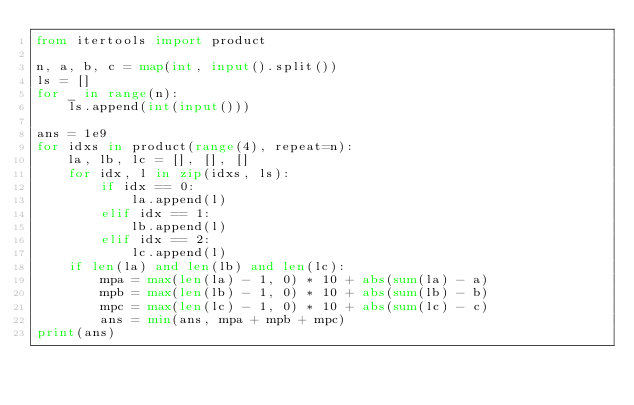<code> <loc_0><loc_0><loc_500><loc_500><_Python_>from itertools import product

n, a, b, c = map(int, input().split())
ls = []
for _ in range(n):
    ls.append(int(input()))

ans = 1e9
for idxs in product(range(4), repeat=n):
    la, lb, lc = [], [], []
    for idx, l in zip(idxs, ls):
        if idx == 0:
            la.append(l)
        elif idx == 1:
            lb.append(l)
        elif idx == 2:
            lc.append(l)
    if len(la) and len(lb) and len(lc):
        mpa = max(len(la) - 1, 0) * 10 + abs(sum(la) - a)
        mpb = max(len(lb) - 1, 0) * 10 + abs(sum(lb) - b)
        mpc = max(len(lc) - 1, 0) * 10 + abs(sum(lc) - c)
        ans = min(ans, mpa + mpb + mpc)
print(ans)
</code> 